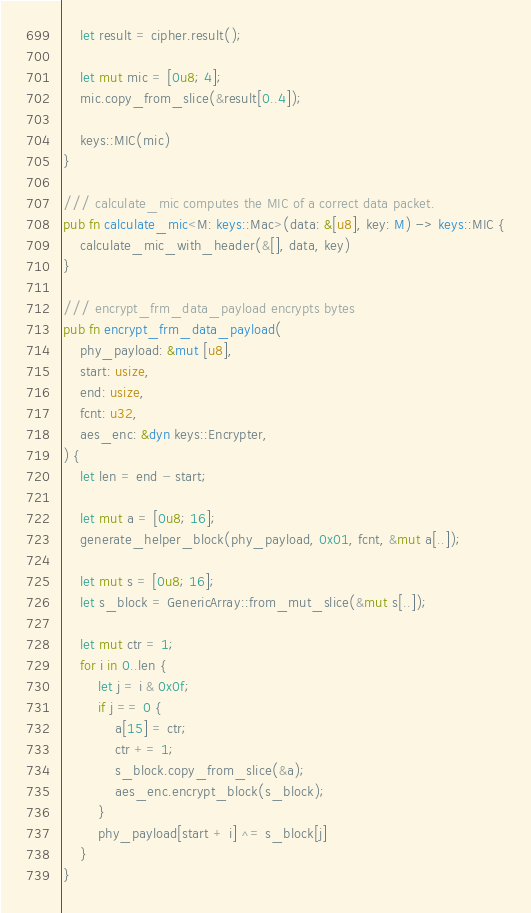Convert code to text. <code><loc_0><loc_0><loc_500><loc_500><_Rust_>    let result = cipher.result();

    let mut mic = [0u8; 4];
    mic.copy_from_slice(&result[0..4]);

    keys::MIC(mic)
}

/// calculate_mic computes the MIC of a correct data packet.
pub fn calculate_mic<M: keys::Mac>(data: &[u8], key: M) -> keys::MIC {
    calculate_mic_with_header(&[], data, key)
}

/// encrypt_frm_data_payload encrypts bytes
pub fn encrypt_frm_data_payload(
    phy_payload: &mut [u8],
    start: usize,
    end: usize,
    fcnt: u32,
    aes_enc: &dyn keys::Encrypter,
) {
    let len = end - start;

    let mut a = [0u8; 16];
    generate_helper_block(phy_payload, 0x01, fcnt, &mut a[..]);

    let mut s = [0u8; 16];
    let s_block = GenericArray::from_mut_slice(&mut s[..]);

    let mut ctr = 1;
    for i in 0..len {
        let j = i & 0x0f;
        if j == 0 {
            a[15] = ctr;
            ctr += 1;
            s_block.copy_from_slice(&a);
            aes_enc.encrypt_block(s_block);
        }
        phy_payload[start + i] ^= s_block[j]
    }
}
</code> 